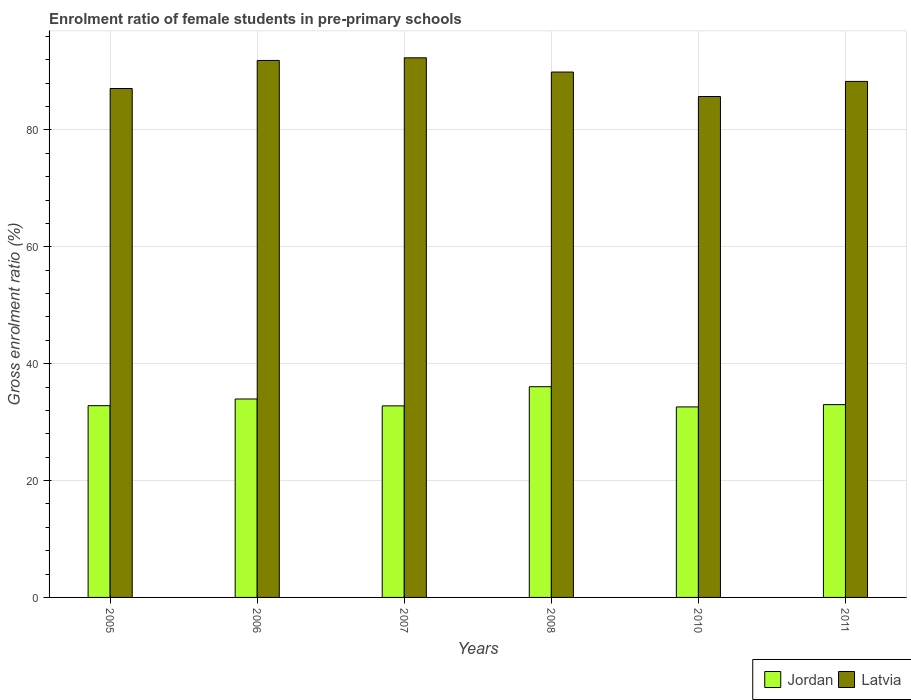How many different coloured bars are there?
Your answer should be very brief. 2. Are the number of bars on each tick of the X-axis equal?
Provide a short and direct response. Yes. How many bars are there on the 4th tick from the right?
Give a very brief answer. 2. What is the label of the 4th group of bars from the left?
Offer a very short reply. 2008. What is the enrolment ratio of female students in pre-primary schools in Latvia in 2005?
Offer a terse response. 87.09. Across all years, what is the maximum enrolment ratio of female students in pre-primary schools in Latvia?
Ensure brevity in your answer.  92.34. Across all years, what is the minimum enrolment ratio of female students in pre-primary schools in Latvia?
Offer a terse response. 85.72. What is the total enrolment ratio of female students in pre-primary schools in Jordan in the graph?
Make the answer very short. 201.2. What is the difference between the enrolment ratio of female students in pre-primary schools in Jordan in 2006 and that in 2008?
Your response must be concise. -2.1. What is the difference between the enrolment ratio of female students in pre-primary schools in Jordan in 2011 and the enrolment ratio of female students in pre-primary schools in Latvia in 2010?
Offer a terse response. -52.72. What is the average enrolment ratio of female students in pre-primary schools in Jordan per year?
Your answer should be very brief. 33.53. In the year 2010, what is the difference between the enrolment ratio of female students in pre-primary schools in Latvia and enrolment ratio of female students in pre-primary schools in Jordan?
Your answer should be very brief. 53.12. What is the ratio of the enrolment ratio of female students in pre-primary schools in Jordan in 2010 to that in 2011?
Offer a very short reply. 0.99. What is the difference between the highest and the second highest enrolment ratio of female students in pre-primary schools in Jordan?
Provide a succinct answer. 2.1. What is the difference between the highest and the lowest enrolment ratio of female students in pre-primary schools in Jordan?
Provide a short and direct response. 3.46. Is the sum of the enrolment ratio of female students in pre-primary schools in Latvia in 2007 and 2010 greater than the maximum enrolment ratio of female students in pre-primary schools in Jordan across all years?
Make the answer very short. Yes. What does the 2nd bar from the left in 2006 represents?
Your response must be concise. Latvia. What does the 2nd bar from the right in 2006 represents?
Your answer should be very brief. Jordan. How many bars are there?
Your response must be concise. 12. How many years are there in the graph?
Offer a terse response. 6. What is the difference between two consecutive major ticks on the Y-axis?
Provide a short and direct response. 20. Are the values on the major ticks of Y-axis written in scientific E-notation?
Offer a terse response. No. Does the graph contain any zero values?
Your answer should be very brief. No. Does the graph contain grids?
Make the answer very short. Yes. How many legend labels are there?
Ensure brevity in your answer.  2. What is the title of the graph?
Offer a terse response. Enrolment ratio of female students in pre-primary schools. Does "Sierra Leone" appear as one of the legend labels in the graph?
Ensure brevity in your answer.  No. What is the label or title of the Y-axis?
Your answer should be compact. Gross enrolment ratio (%). What is the Gross enrolment ratio (%) in Jordan in 2005?
Give a very brief answer. 32.81. What is the Gross enrolment ratio (%) of Latvia in 2005?
Provide a succinct answer. 87.09. What is the Gross enrolment ratio (%) in Jordan in 2006?
Make the answer very short. 33.96. What is the Gross enrolment ratio (%) of Latvia in 2006?
Ensure brevity in your answer.  91.89. What is the Gross enrolment ratio (%) of Jordan in 2007?
Provide a succinct answer. 32.78. What is the Gross enrolment ratio (%) in Latvia in 2007?
Your response must be concise. 92.34. What is the Gross enrolment ratio (%) in Jordan in 2008?
Provide a short and direct response. 36.06. What is the Gross enrolment ratio (%) of Latvia in 2008?
Your answer should be very brief. 89.9. What is the Gross enrolment ratio (%) in Jordan in 2010?
Make the answer very short. 32.6. What is the Gross enrolment ratio (%) of Latvia in 2010?
Give a very brief answer. 85.72. What is the Gross enrolment ratio (%) in Jordan in 2011?
Your response must be concise. 32.99. What is the Gross enrolment ratio (%) of Latvia in 2011?
Provide a short and direct response. 88.3. Across all years, what is the maximum Gross enrolment ratio (%) in Jordan?
Your answer should be very brief. 36.06. Across all years, what is the maximum Gross enrolment ratio (%) of Latvia?
Offer a terse response. 92.34. Across all years, what is the minimum Gross enrolment ratio (%) in Jordan?
Your answer should be very brief. 32.6. Across all years, what is the minimum Gross enrolment ratio (%) in Latvia?
Offer a very short reply. 85.72. What is the total Gross enrolment ratio (%) in Jordan in the graph?
Keep it short and to the point. 201.2. What is the total Gross enrolment ratio (%) of Latvia in the graph?
Provide a succinct answer. 535.23. What is the difference between the Gross enrolment ratio (%) of Jordan in 2005 and that in 2006?
Your answer should be compact. -1.14. What is the difference between the Gross enrolment ratio (%) of Latvia in 2005 and that in 2006?
Keep it short and to the point. -4.8. What is the difference between the Gross enrolment ratio (%) of Jordan in 2005 and that in 2007?
Offer a very short reply. 0.03. What is the difference between the Gross enrolment ratio (%) of Latvia in 2005 and that in 2007?
Your response must be concise. -5.25. What is the difference between the Gross enrolment ratio (%) in Jordan in 2005 and that in 2008?
Provide a short and direct response. -3.25. What is the difference between the Gross enrolment ratio (%) of Latvia in 2005 and that in 2008?
Make the answer very short. -2.82. What is the difference between the Gross enrolment ratio (%) in Jordan in 2005 and that in 2010?
Provide a short and direct response. 0.21. What is the difference between the Gross enrolment ratio (%) in Latvia in 2005 and that in 2010?
Make the answer very short. 1.37. What is the difference between the Gross enrolment ratio (%) in Jordan in 2005 and that in 2011?
Offer a very short reply. -0.18. What is the difference between the Gross enrolment ratio (%) of Latvia in 2005 and that in 2011?
Your answer should be compact. -1.21. What is the difference between the Gross enrolment ratio (%) in Jordan in 2006 and that in 2007?
Provide a short and direct response. 1.18. What is the difference between the Gross enrolment ratio (%) of Latvia in 2006 and that in 2007?
Your answer should be compact. -0.45. What is the difference between the Gross enrolment ratio (%) of Jordan in 2006 and that in 2008?
Your answer should be compact. -2.1. What is the difference between the Gross enrolment ratio (%) of Latvia in 2006 and that in 2008?
Offer a very short reply. 1.99. What is the difference between the Gross enrolment ratio (%) of Jordan in 2006 and that in 2010?
Offer a very short reply. 1.36. What is the difference between the Gross enrolment ratio (%) of Latvia in 2006 and that in 2010?
Provide a short and direct response. 6.17. What is the difference between the Gross enrolment ratio (%) of Jordan in 2006 and that in 2011?
Ensure brevity in your answer.  0.96. What is the difference between the Gross enrolment ratio (%) in Latvia in 2006 and that in 2011?
Provide a short and direct response. 3.59. What is the difference between the Gross enrolment ratio (%) in Jordan in 2007 and that in 2008?
Give a very brief answer. -3.28. What is the difference between the Gross enrolment ratio (%) in Latvia in 2007 and that in 2008?
Your answer should be compact. 2.44. What is the difference between the Gross enrolment ratio (%) of Jordan in 2007 and that in 2010?
Keep it short and to the point. 0.18. What is the difference between the Gross enrolment ratio (%) of Latvia in 2007 and that in 2010?
Your response must be concise. 6.62. What is the difference between the Gross enrolment ratio (%) in Jordan in 2007 and that in 2011?
Offer a terse response. -0.22. What is the difference between the Gross enrolment ratio (%) of Latvia in 2007 and that in 2011?
Keep it short and to the point. 4.04. What is the difference between the Gross enrolment ratio (%) in Jordan in 2008 and that in 2010?
Offer a very short reply. 3.46. What is the difference between the Gross enrolment ratio (%) in Latvia in 2008 and that in 2010?
Keep it short and to the point. 4.18. What is the difference between the Gross enrolment ratio (%) of Jordan in 2008 and that in 2011?
Your answer should be compact. 3.06. What is the difference between the Gross enrolment ratio (%) in Latvia in 2008 and that in 2011?
Ensure brevity in your answer.  1.6. What is the difference between the Gross enrolment ratio (%) of Jordan in 2010 and that in 2011?
Offer a terse response. -0.4. What is the difference between the Gross enrolment ratio (%) in Latvia in 2010 and that in 2011?
Provide a succinct answer. -2.58. What is the difference between the Gross enrolment ratio (%) of Jordan in 2005 and the Gross enrolment ratio (%) of Latvia in 2006?
Provide a short and direct response. -59.07. What is the difference between the Gross enrolment ratio (%) of Jordan in 2005 and the Gross enrolment ratio (%) of Latvia in 2007?
Offer a terse response. -59.53. What is the difference between the Gross enrolment ratio (%) in Jordan in 2005 and the Gross enrolment ratio (%) in Latvia in 2008?
Your answer should be compact. -57.09. What is the difference between the Gross enrolment ratio (%) of Jordan in 2005 and the Gross enrolment ratio (%) of Latvia in 2010?
Ensure brevity in your answer.  -52.9. What is the difference between the Gross enrolment ratio (%) in Jordan in 2005 and the Gross enrolment ratio (%) in Latvia in 2011?
Offer a terse response. -55.49. What is the difference between the Gross enrolment ratio (%) of Jordan in 2006 and the Gross enrolment ratio (%) of Latvia in 2007?
Keep it short and to the point. -58.38. What is the difference between the Gross enrolment ratio (%) in Jordan in 2006 and the Gross enrolment ratio (%) in Latvia in 2008?
Your answer should be compact. -55.95. What is the difference between the Gross enrolment ratio (%) in Jordan in 2006 and the Gross enrolment ratio (%) in Latvia in 2010?
Keep it short and to the point. -51.76. What is the difference between the Gross enrolment ratio (%) of Jordan in 2006 and the Gross enrolment ratio (%) of Latvia in 2011?
Provide a short and direct response. -54.34. What is the difference between the Gross enrolment ratio (%) in Jordan in 2007 and the Gross enrolment ratio (%) in Latvia in 2008?
Offer a terse response. -57.12. What is the difference between the Gross enrolment ratio (%) in Jordan in 2007 and the Gross enrolment ratio (%) in Latvia in 2010?
Offer a terse response. -52.94. What is the difference between the Gross enrolment ratio (%) of Jordan in 2007 and the Gross enrolment ratio (%) of Latvia in 2011?
Offer a terse response. -55.52. What is the difference between the Gross enrolment ratio (%) in Jordan in 2008 and the Gross enrolment ratio (%) in Latvia in 2010?
Offer a very short reply. -49.66. What is the difference between the Gross enrolment ratio (%) in Jordan in 2008 and the Gross enrolment ratio (%) in Latvia in 2011?
Your answer should be very brief. -52.24. What is the difference between the Gross enrolment ratio (%) in Jordan in 2010 and the Gross enrolment ratio (%) in Latvia in 2011?
Offer a very short reply. -55.7. What is the average Gross enrolment ratio (%) in Jordan per year?
Offer a very short reply. 33.53. What is the average Gross enrolment ratio (%) in Latvia per year?
Your response must be concise. 89.21. In the year 2005, what is the difference between the Gross enrolment ratio (%) in Jordan and Gross enrolment ratio (%) in Latvia?
Make the answer very short. -54.27. In the year 2006, what is the difference between the Gross enrolment ratio (%) of Jordan and Gross enrolment ratio (%) of Latvia?
Your response must be concise. -57.93. In the year 2007, what is the difference between the Gross enrolment ratio (%) of Jordan and Gross enrolment ratio (%) of Latvia?
Keep it short and to the point. -59.56. In the year 2008, what is the difference between the Gross enrolment ratio (%) in Jordan and Gross enrolment ratio (%) in Latvia?
Give a very brief answer. -53.84. In the year 2010, what is the difference between the Gross enrolment ratio (%) in Jordan and Gross enrolment ratio (%) in Latvia?
Give a very brief answer. -53.12. In the year 2011, what is the difference between the Gross enrolment ratio (%) of Jordan and Gross enrolment ratio (%) of Latvia?
Your answer should be compact. -55.31. What is the ratio of the Gross enrolment ratio (%) of Jordan in 2005 to that in 2006?
Provide a short and direct response. 0.97. What is the ratio of the Gross enrolment ratio (%) of Latvia in 2005 to that in 2006?
Keep it short and to the point. 0.95. What is the ratio of the Gross enrolment ratio (%) of Latvia in 2005 to that in 2007?
Your answer should be compact. 0.94. What is the ratio of the Gross enrolment ratio (%) in Jordan in 2005 to that in 2008?
Offer a very short reply. 0.91. What is the ratio of the Gross enrolment ratio (%) of Latvia in 2005 to that in 2008?
Your answer should be compact. 0.97. What is the ratio of the Gross enrolment ratio (%) in Jordan in 2005 to that in 2010?
Offer a terse response. 1.01. What is the ratio of the Gross enrolment ratio (%) in Latvia in 2005 to that in 2011?
Your answer should be very brief. 0.99. What is the ratio of the Gross enrolment ratio (%) in Jordan in 2006 to that in 2007?
Your response must be concise. 1.04. What is the ratio of the Gross enrolment ratio (%) in Latvia in 2006 to that in 2007?
Offer a very short reply. 1. What is the ratio of the Gross enrolment ratio (%) of Jordan in 2006 to that in 2008?
Your answer should be compact. 0.94. What is the ratio of the Gross enrolment ratio (%) of Latvia in 2006 to that in 2008?
Make the answer very short. 1.02. What is the ratio of the Gross enrolment ratio (%) of Jordan in 2006 to that in 2010?
Give a very brief answer. 1.04. What is the ratio of the Gross enrolment ratio (%) of Latvia in 2006 to that in 2010?
Provide a short and direct response. 1.07. What is the ratio of the Gross enrolment ratio (%) in Jordan in 2006 to that in 2011?
Your answer should be compact. 1.03. What is the ratio of the Gross enrolment ratio (%) of Latvia in 2006 to that in 2011?
Offer a very short reply. 1.04. What is the ratio of the Gross enrolment ratio (%) in Jordan in 2007 to that in 2008?
Your response must be concise. 0.91. What is the ratio of the Gross enrolment ratio (%) of Latvia in 2007 to that in 2008?
Offer a terse response. 1.03. What is the ratio of the Gross enrolment ratio (%) in Latvia in 2007 to that in 2010?
Make the answer very short. 1.08. What is the ratio of the Gross enrolment ratio (%) of Jordan in 2007 to that in 2011?
Provide a short and direct response. 0.99. What is the ratio of the Gross enrolment ratio (%) of Latvia in 2007 to that in 2011?
Your response must be concise. 1.05. What is the ratio of the Gross enrolment ratio (%) of Jordan in 2008 to that in 2010?
Offer a terse response. 1.11. What is the ratio of the Gross enrolment ratio (%) in Latvia in 2008 to that in 2010?
Your answer should be compact. 1.05. What is the ratio of the Gross enrolment ratio (%) of Jordan in 2008 to that in 2011?
Offer a very short reply. 1.09. What is the ratio of the Gross enrolment ratio (%) in Latvia in 2008 to that in 2011?
Offer a terse response. 1.02. What is the ratio of the Gross enrolment ratio (%) of Jordan in 2010 to that in 2011?
Your answer should be compact. 0.99. What is the ratio of the Gross enrolment ratio (%) of Latvia in 2010 to that in 2011?
Your answer should be compact. 0.97. What is the difference between the highest and the second highest Gross enrolment ratio (%) in Jordan?
Ensure brevity in your answer.  2.1. What is the difference between the highest and the second highest Gross enrolment ratio (%) of Latvia?
Offer a terse response. 0.45. What is the difference between the highest and the lowest Gross enrolment ratio (%) of Jordan?
Your answer should be very brief. 3.46. What is the difference between the highest and the lowest Gross enrolment ratio (%) in Latvia?
Keep it short and to the point. 6.62. 